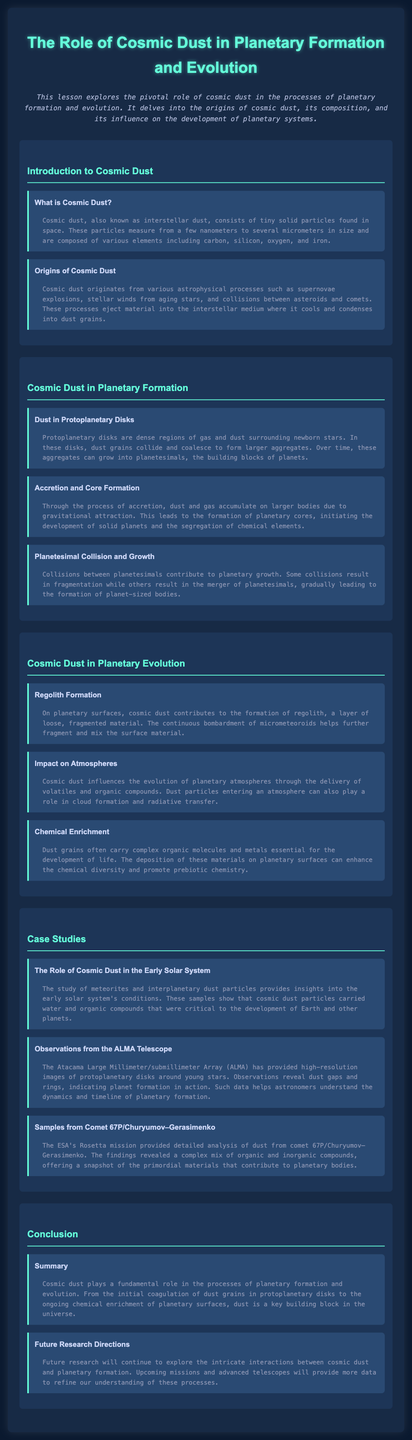What is cosmic dust? Cosmic dust is defined in the document as tiny solid particles found in space, measuring from a few nanometers to several micrometers in size, composed of various elements.
Answer: Tiny solid particles found in space What are the origins of cosmic dust? The document states that cosmic dust originates from astrophysical processes such as supernovae explosions, stellar winds, and collisions between asteroids and comets.
Answer: Supernovae explosions, stellar winds, collisions What is the role of dust in protoplanetary disks? Dust grains in protoplanetary disks collide and coalesce to form larger aggregates, leading to the formation of planetesimals.
Answer: Form larger aggregates What is regolith? Regolith is described in the document as a layer of loose, fragmented material on planetary surfaces formed by cosmic dust.
Answer: Layer of loose, fragmented material Which telescope provided insights into protoplanetary disks? The Atacama Large Millimeter/submillimeter Array (ALMA) is mentioned in the document as providing high-resolution images of protoplanetary disks.
Answer: ALMA What are the future research directions mentioned in the lesson plan? The document highlights that upcoming missions and advanced telescopes will continue to explore the interactions between cosmic dust and planetary formation.
Answer: Upcoming missions and advanced telescopes How does cosmic dust impact planetary atmospheres? Cosmic dust influences planetary atmospheres through the delivery of volatiles and organic compounds, playing a role in cloud formation.
Answer: Delivery of volatiles and organic compounds What was revealed by the analysis of dust from comet 67P? The analysis from the ESA's Rosetta mission revealed a complex mix of organic and inorganic compounds.
Answer: Complex mix of organic and inorganic compounds 